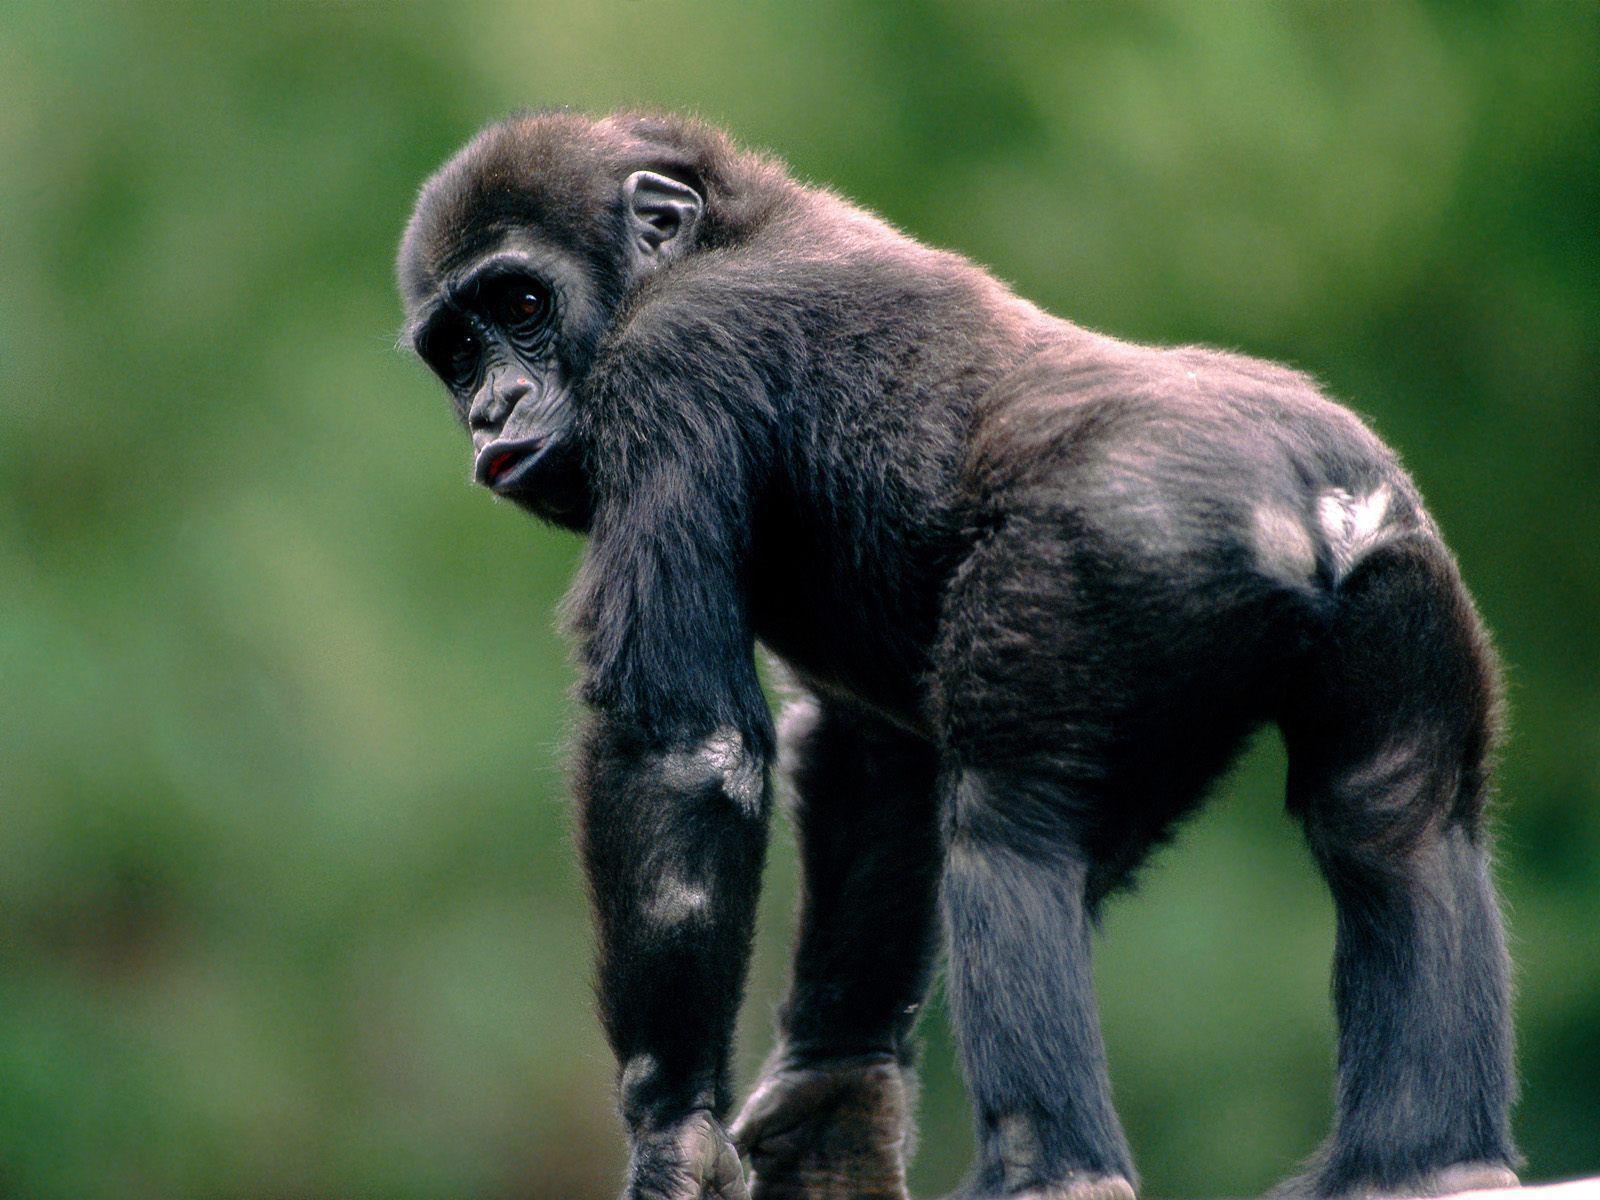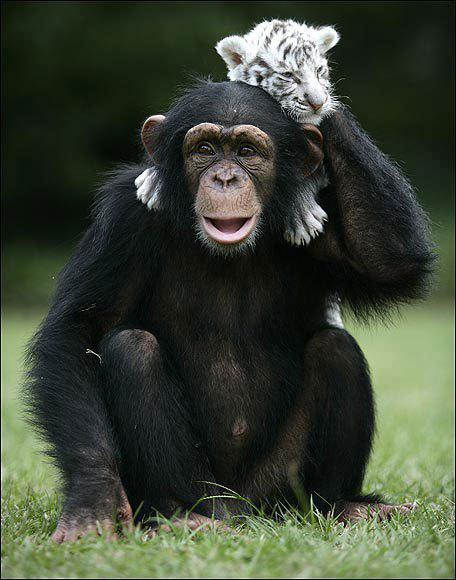The first image is the image on the left, the second image is the image on the right. For the images displayed, is the sentence "The right image shows a chimp with an animal on its back." factually correct? Answer yes or no. Yes. The first image is the image on the left, the second image is the image on the right. Considering the images on both sides, is "The image on the right contains a baby and its mother." valid? Answer yes or no. No. 